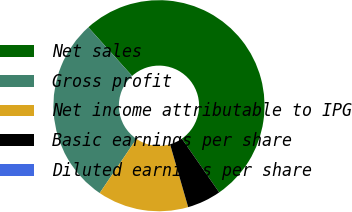<chart> <loc_0><loc_0><loc_500><loc_500><pie_chart><fcel>Net sales<fcel>Gross profit<fcel>Net income attributable to IPG<fcel>Basic earnings per share<fcel>Diluted earnings per share<nl><fcel>52.01%<fcel>28.84%<fcel>13.95%<fcel>5.2%<fcel>0.0%<nl></chart> 